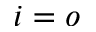<formula> <loc_0><loc_0><loc_500><loc_500>i = o</formula> 